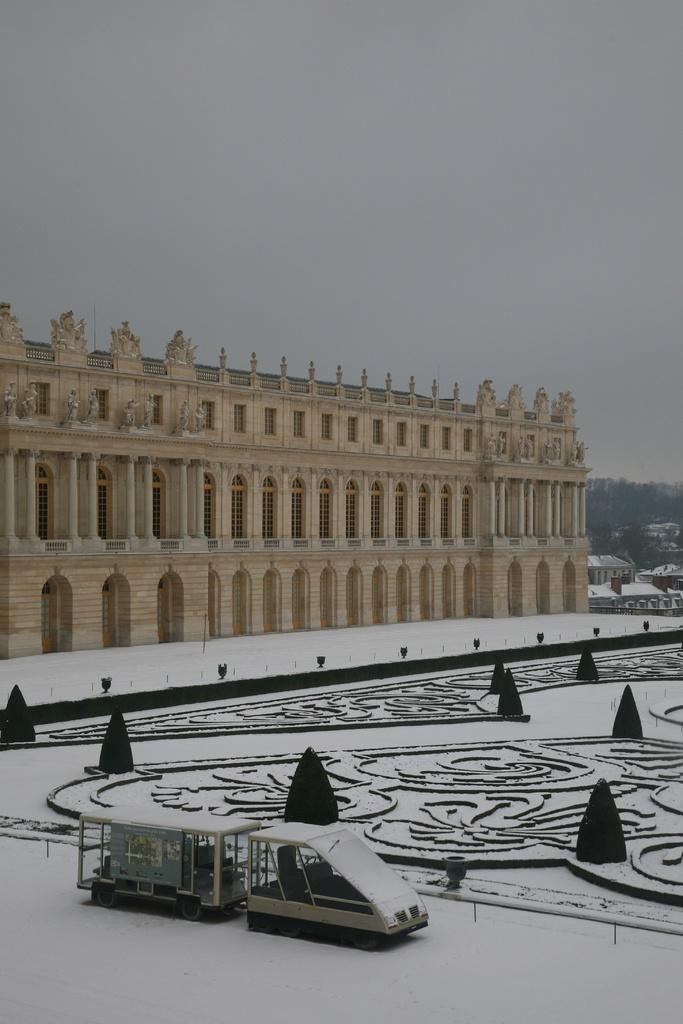What is the condition of the roads in the image? The roads in the image are covered with snow. What type of structures can be seen in the image? There are buildings visible in the image. What mode of transportation is present in the image? A motor vehicle is present in the image. What type of natural elements are present in the image? Trees are present in the image. What is visible in the background of the image? The sky is visible in the image. What type of dress is hanging on the tree in the image? There is no dress hanging on the tree in the image; trees are present, but no dresses are mentioned in the facts. What material is the steel used for in the image? There is no mention of steel or any other specific materials in the image. 